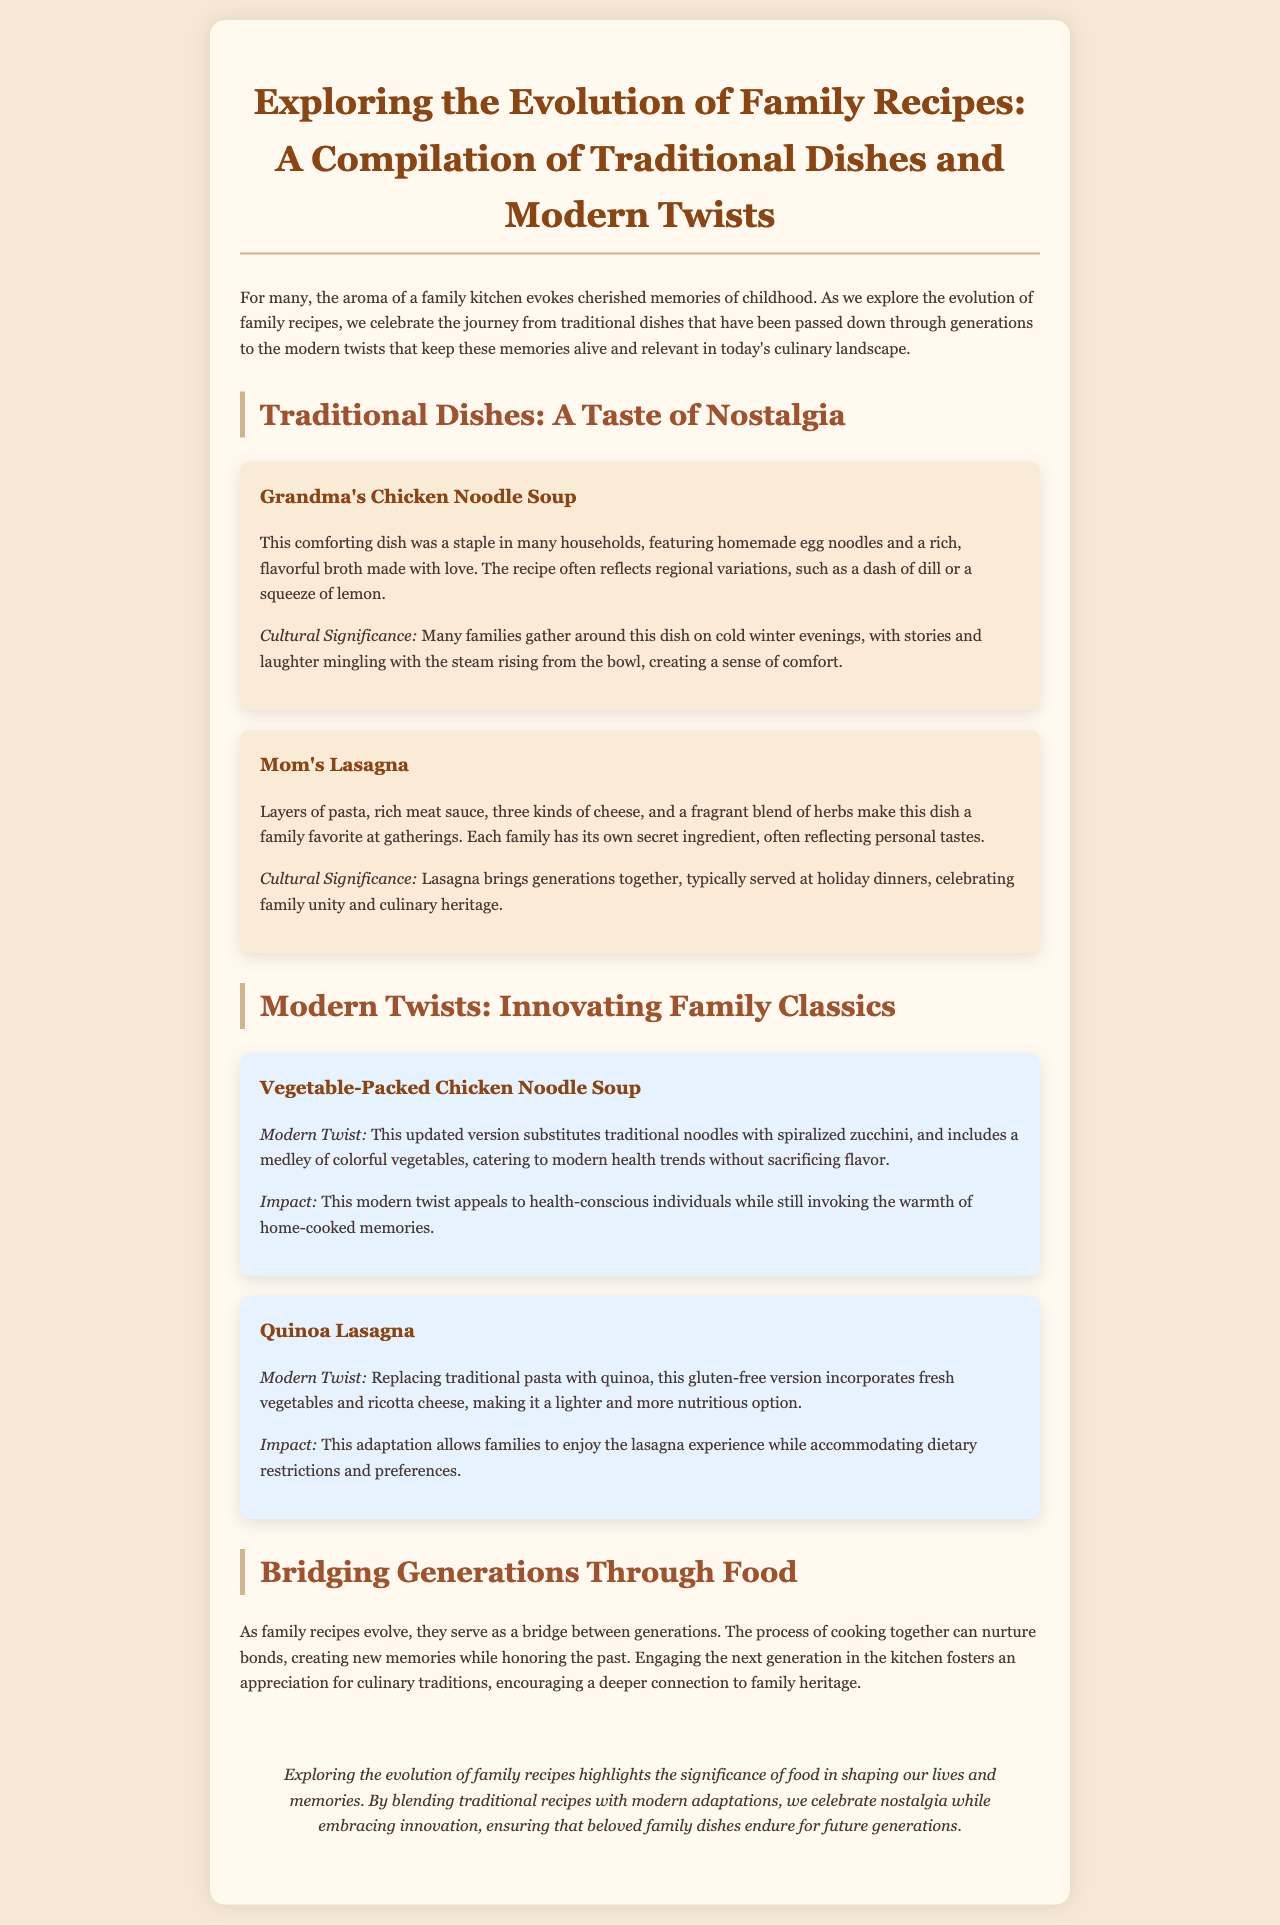What is the title of the document? The title can be found prominently displayed at the top of the document.
Answer: Exploring the Evolution of Family Recipes: A Compilation of Traditional Dishes and Modern Twists What dish is mentioned as Grandma's specialty? This dish is highlighted as a traditional family meal and linked to personal memories, reflecting nostalgia.
Answer: Grandma's Chicken Noodle Soup What modern twist is given to Chicken Noodle Soup? The modern adaptation is listed under the section discussing innovations to traditional recipes.
Answer: Vegetable-Packed Chicken Noodle Soup How many types of lasagna are discussed in the document? This can be determined by counting the mentions of lasagna in different sections of the report.
Answer: Two What ingredient is used in the modern twist of lasagna? This specific ingredient is highlighted in the description of the modern adaptation.
Answer: Quinoa What is the cultural significance of Mom's Lasagna? The explanation can be found in the description under cultural insights connecting the dish to family gatherings.
Answer: Celebrating family unity and culinary heritage What does the document suggest about the impact of evolving family recipes? The document highlights the effect of cooking together in building relationships and memories among family members.
Answer: Nurture bonds What type of layout is used in this document? This question pertains to the format and structure presented across different sections of content.
Answer: Report What color is the background of the body section? The body section's background color is mentioned in the style settings of the document.
Answer: #f7e8d5 